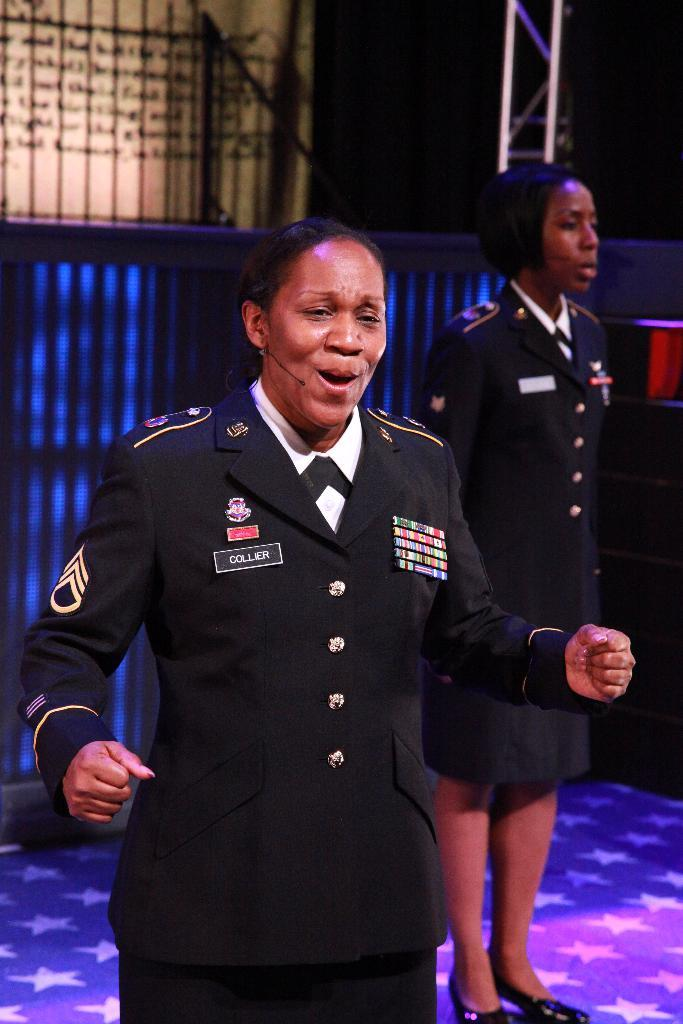How many women are in the image? There are two women in the image. What are the women wearing? The women are wearing officer uniforms. Where are the women standing? The women are standing on the floor. What can be seen on the floor? There is a purple light reflection on the floor. What is visible in the background? There is a wall with railing in the background. Can you hear the sound of a van driving by in the image? There is no sound or van present in the image; it is a still photograph. 